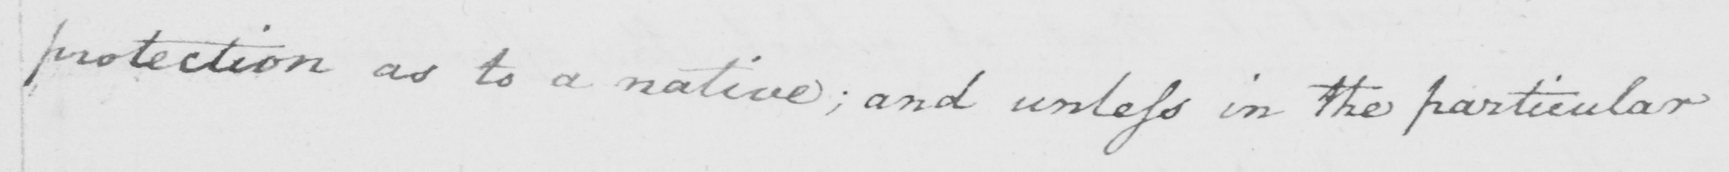Transcribe the text shown in this historical manuscript line. protection as to a native ; and unless in the particular 